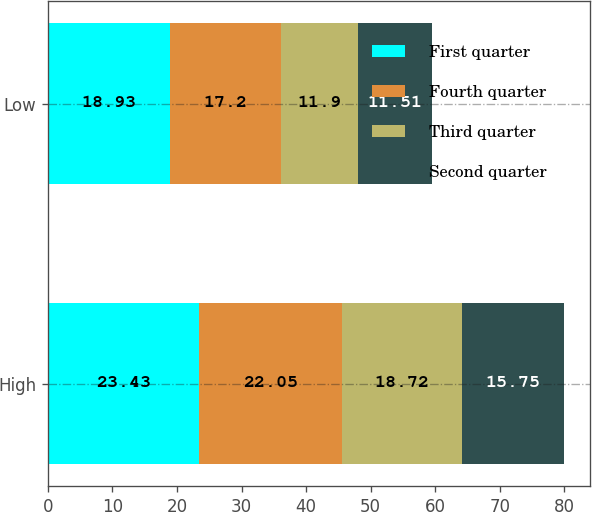Convert chart to OTSL. <chart><loc_0><loc_0><loc_500><loc_500><stacked_bar_chart><ecel><fcel>High<fcel>Low<nl><fcel>First quarter<fcel>23.43<fcel>18.93<nl><fcel>Fourth quarter<fcel>22.05<fcel>17.2<nl><fcel>Third quarter<fcel>18.72<fcel>11.9<nl><fcel>Second quarter<fcel>15.75<fcel>11.51<nl></chart> 